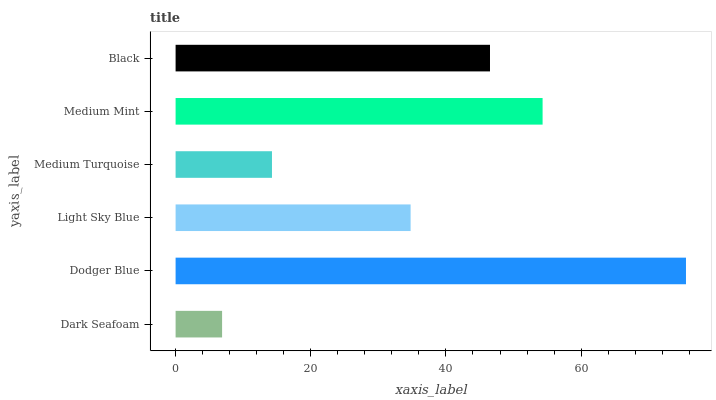Is Dark Seafoam the minimum?
Answer yes or no. Yes. Is Dodger Blue the maximum?
Answer yes or no. Yes. Is Light Sky Blue the minimum?
Answer yes or no. No. Is Light Sky Blue the maximum?
Answer yes or no. No. Is Dodger Blue greater than Light Sky Blue?
Answer yes or no. Yes. Is Light Sky Blue less than Dodger Blue?
Answer yes or no. Yes. Is Light Sky Blue greater than Dodger Blue?
Answer yes or no. No. Is Dodger Blue less than Light Sky Blue?
Answer yes or no. No. Is Black the high median?
Answer yes or no. Yes. Is Light Sky Blue the low median?
Answer yes or no. Yes. Is Medium Mint the high median?
Answer yes or no. No. Is Dodger Blue the low median?
Answer yes or no. No. 